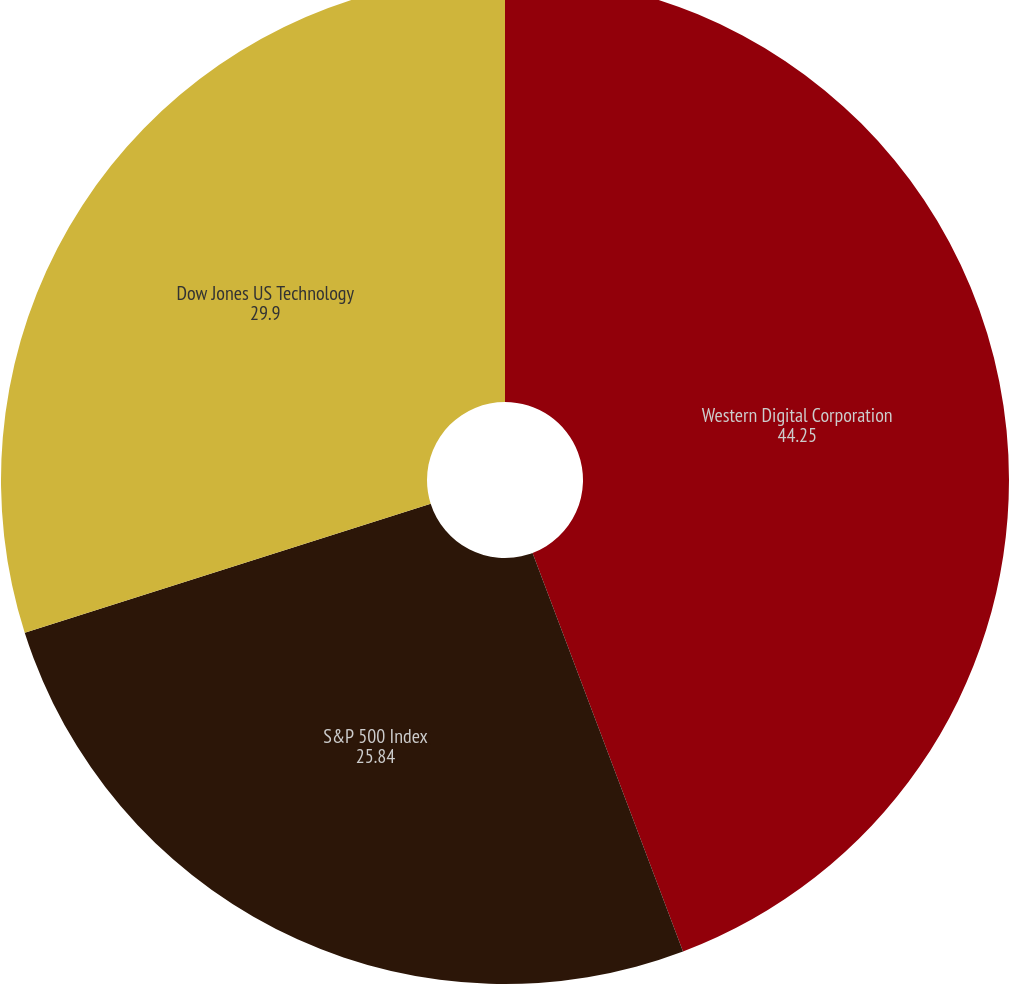Convert chart. <chart><loc_0><loc_0><loc_500><loc_500><pie_chart><fcel>Western Digital Corporation<fcel>S&P 500 Index<fcel>Dow Jones US Technology<nl><fcel>44.25%<fcel>25.84%<fcel>29.9%<nl></chart> 